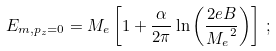Convert formula to latex. <formula><loc_0><loc_0><loc_500><loc_500>E _ { m , p _ { z } = 0 } = M _ { e } \left [ 1 + { \frac { \alpha } { 2 \pi } } \ln \left ( { \frac { 2 e B } { { M _ { e } } ^ { 2 } } } \right ) \right ] \, ;</formula> 